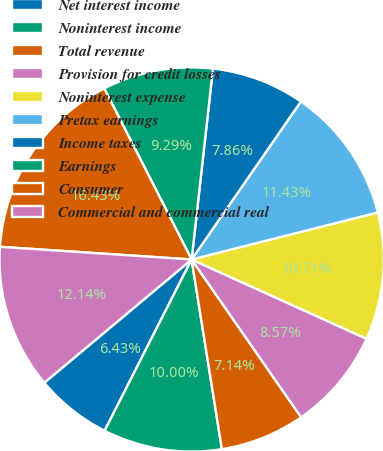Convert chart. <chart><loc_0><loc_0><loc_500><loc_500><pie_chart><fcel>Net interest income<fcel>Noninterest income<fcel>Total revenue<fcel>Provision for credit losses<fcel>Noninterest expense<fcel>Pretax earnings<fcel>Income taxes<fcel>Earnings<fcel>Consumer<fcel>Commercial and commercial real<nl><fcel>6.43%<fcel>10.0%<fcel>7.14%<fcel>8.57%<fcel>10.71%<fcel>11.43%<fcel>7.86%<fcel>9.29%<fcel>16.43%<fcel>12.14%<nl></chart> 